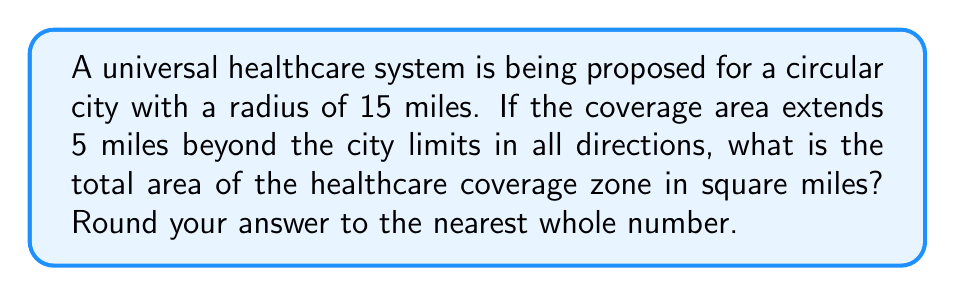Teach me how to tackle this problem. Let's approach this step-by-step:

1) The healthcare coverage zone is a circle that extends 5 miles beyond the city limits in all directions.

2) The radius of the coverage zone is therefore:
   $r = 15 + 5 = 20$ miles

3) The formula for the area of a circle is:
   $A = \pi r^2$

4) Substituting our radius:
   $A = \pi (20)^2$

5) Simplify:
   $A = 400\pi$ square miles

6) Using $\pi \approx 3.14159$:
   $A \approx 400 * 3.14159 = 1256.636$ square miles

7) Rounding to the nearest whole number:
   $A \approx 1257$ square miles

[asy]
unitsize(5mm);
draw(circle((0,0),3), black);
draw(circle((0,0),4), blue);
label("City", (0,0), black);
label("Coverage Zone", (3.5,3.5), blue);
draw((0,0)--(4,0), arrow=Arrow(TeXHead));
label("20 miles", (2,-0.5), black);
[/asy]
Answer: 1257 square miles 